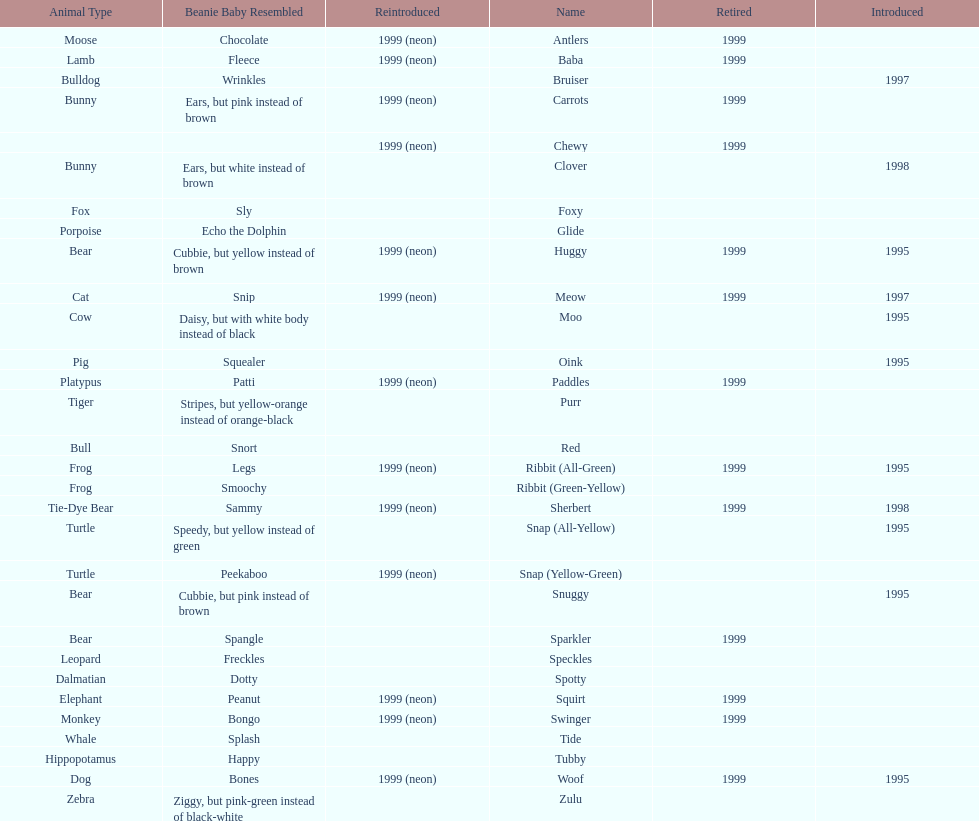What is the name of the last pillow pal on this chart? Zulu. 